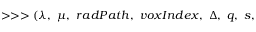Convert formula to latex. <formula><loc_0><loc_0><loc_500><loc_500>> > > ( \lambda , \mu , r a d P a t h , v o x I n d e x , \Delta , q , s ,</formula> 